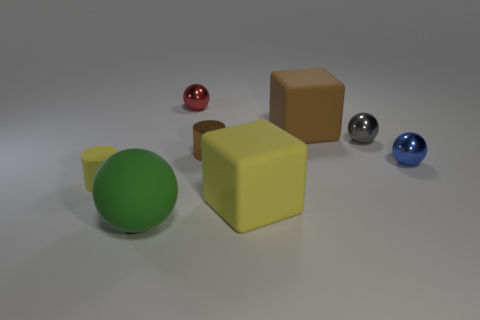What time of day do you think it is in this image based on the lighting? Given the neutral and soft shadows in the image, it suggests an interior setup possibly lit by artificial lighting, which makes it difficult to determine the time of day based on the lighting alone. 